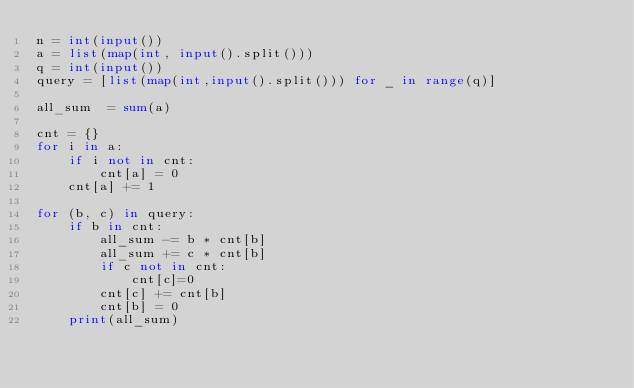<code> <loc_0><loc_0><loc_500><loc_500><_Python_>n = int(input())
a = list(map(int, input().split()))
q = int(input())
query = [list(map(int,input().split())) for _ in range(q)]

all_sum  = sum(a)

cnt = {}
for i in a:
    if i not in cnt:
        cnt[a] = 0
    cnt[a] += 1

for (b, c) in query:
    if b in cnt:
        all_sum -= b * cnt[b]
        all_sum += c * cnt[b]
        if c not in cnt:
            cnt[c]=0 
        cnt[c] += cnt[b]
        cnt[b] = 0
    print(all_sum)</code> 